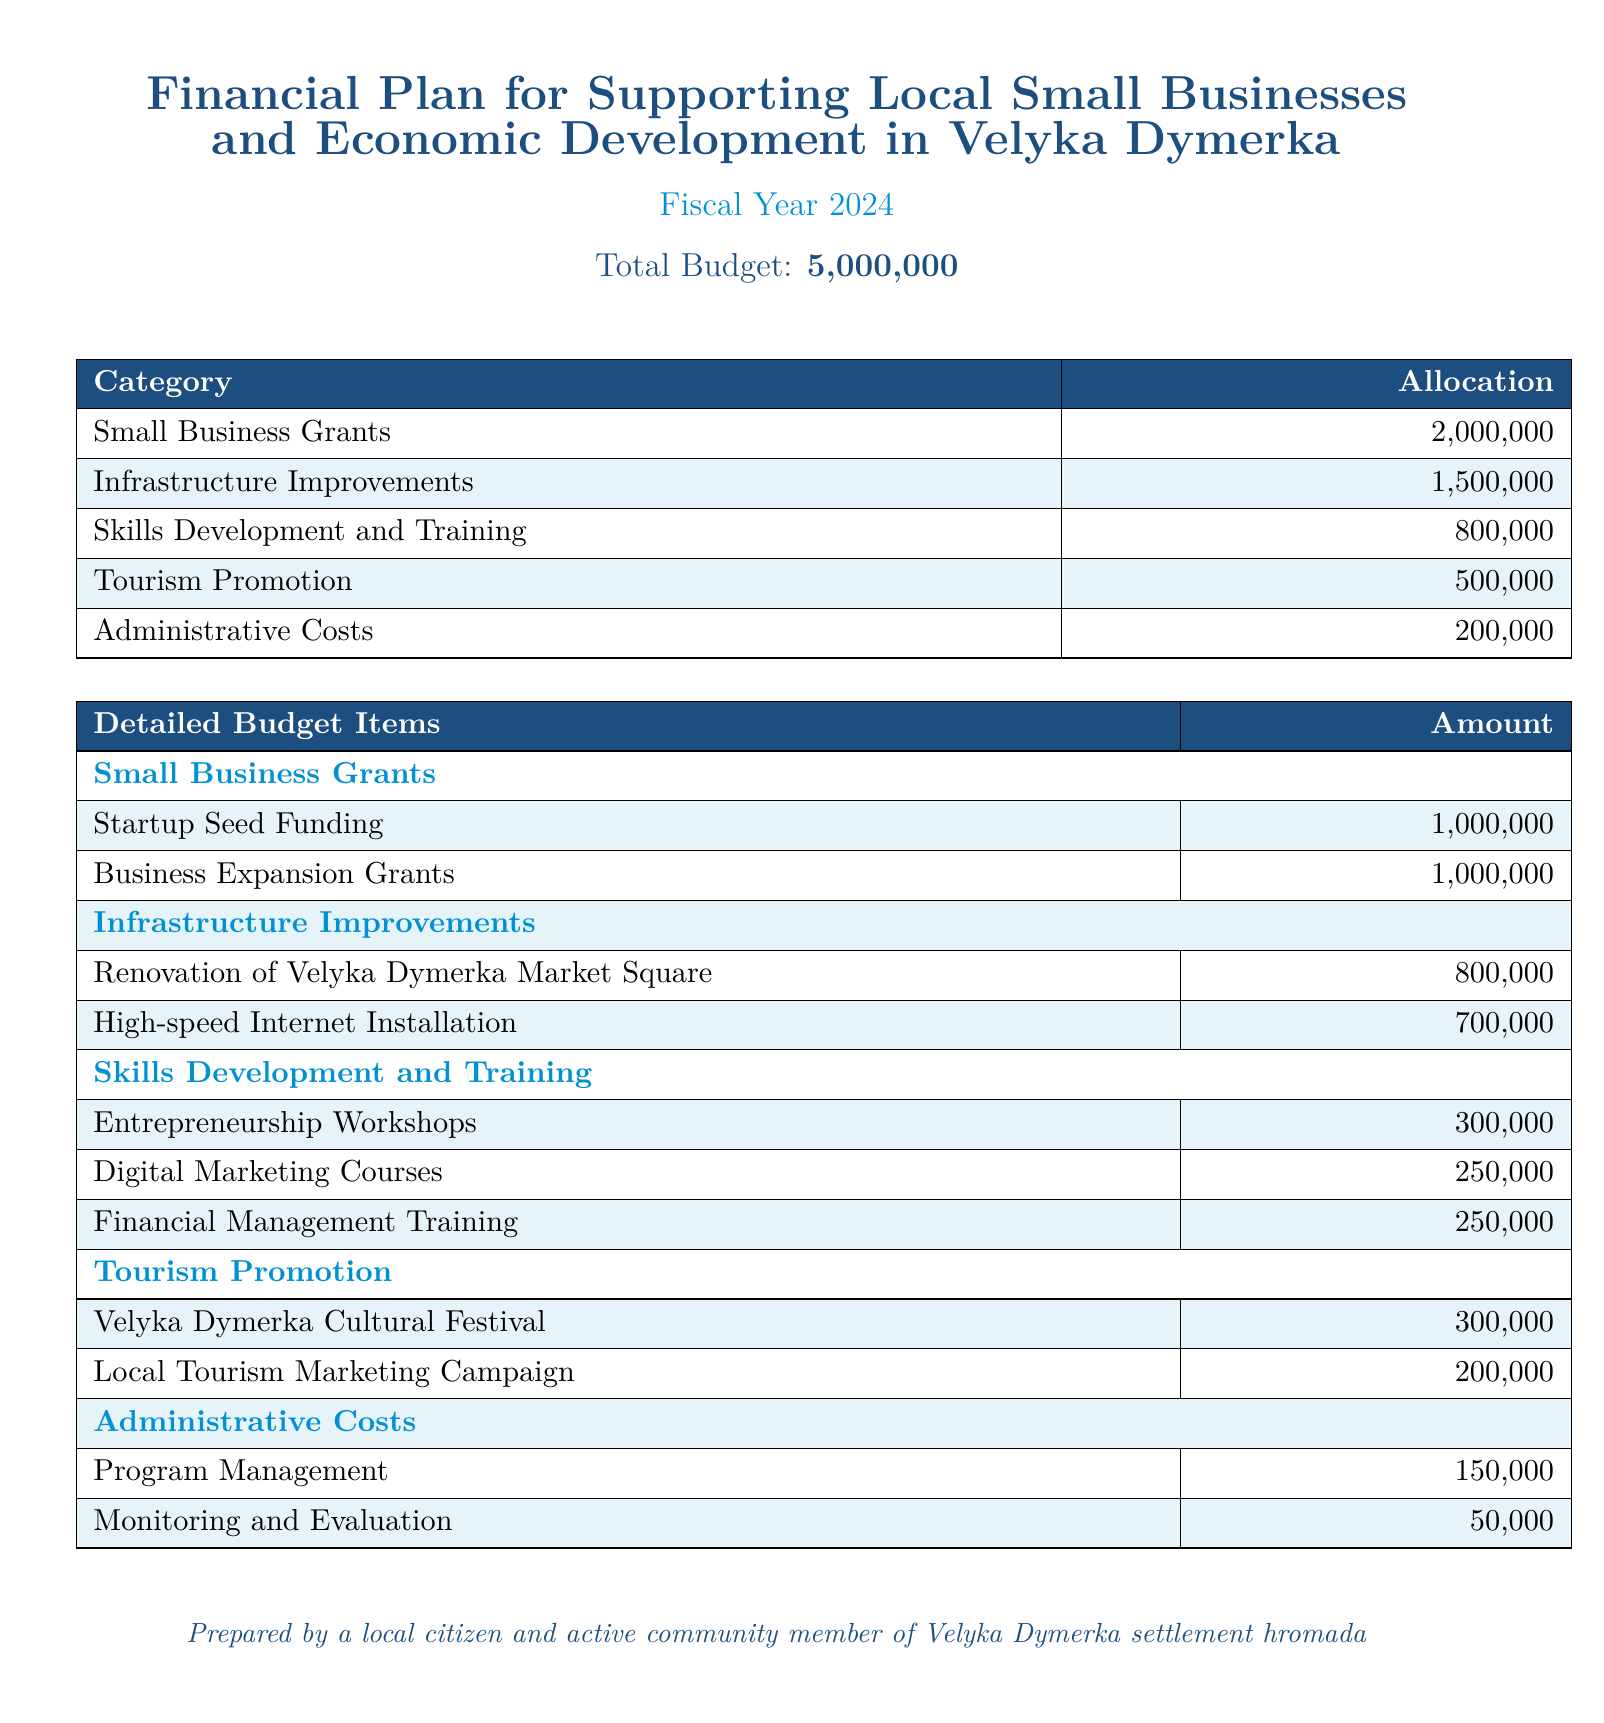What is the total budget? The total budget is stated at the top of the document, which is ₴5,000,000.
Answer: ₴5,000,000 How much is allocated for Small Business Grants? The allocation for Small Business Grants is provided in the budget table, which shows ₴2,000,000.
Answer: ₴2,000,000 What is the amount for Skills Development and Training? The budget specifically lists the amount for Skills Development and Training, which is ₴800,000.
Answer: ₴800,000 Which project has the highest allocation under Infrastructure Improvements? The highest allocation within Infrastructure Improvements is for the Renovation of Velyka Dymerka Market Square, which is ₴800,000.
Answer: Renovation of Velyka Dymerka Market Square How much is allocated to the Velyka Dymerka Cultural Festival? The budget details state the allocation for the Velyka Dymerka Cultural Festival, which is ₴300,000.
Answer: ₴300,000 What is the total amount allocated for Administrative Costs? The total for Administrative Costs is combined as ₴150,000 for Program Management and ₴50,000 for Monitoring and Evaluation, totaling ₴200,000.
Answer: ₴200,000 What percentage of the total budget is allocated to Tourism Promotion? Tourism Promotion's allocation of ₴500,000 out of the total budget of ₴5,000,000 represents 10%.
Answer: 10% Which category has the lowest budget allocation? Based on the budget allocations listed, Administrative Costs has the lowest allocation at ₴200,000.
Answer: Administrative Costs How many types of training are included in Skills Development? The document lists three different types of training under Skills Development and Training.
Answer: Three 